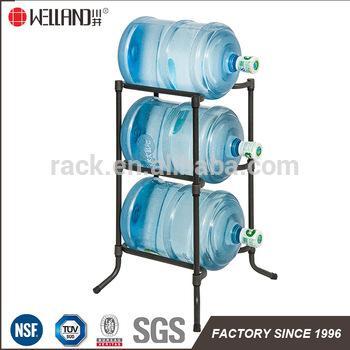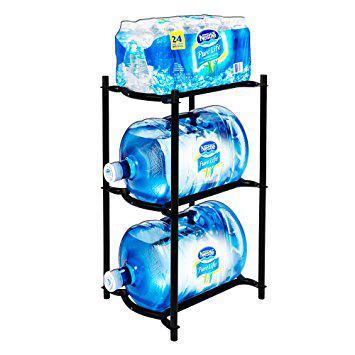The first image is the image on the left, the second image is the image on the right. Considering the images on both sides, is "Every image has a fully stocked tower of blue water jugs with at least three levels." valid? Answer yes or no. Yes. The first image is the image on the left, the second image is the image on the right. For the images displayed, is the sentence "An image contains a rack holding large water bottles." factually correct? Answer yes or no. Yes. 